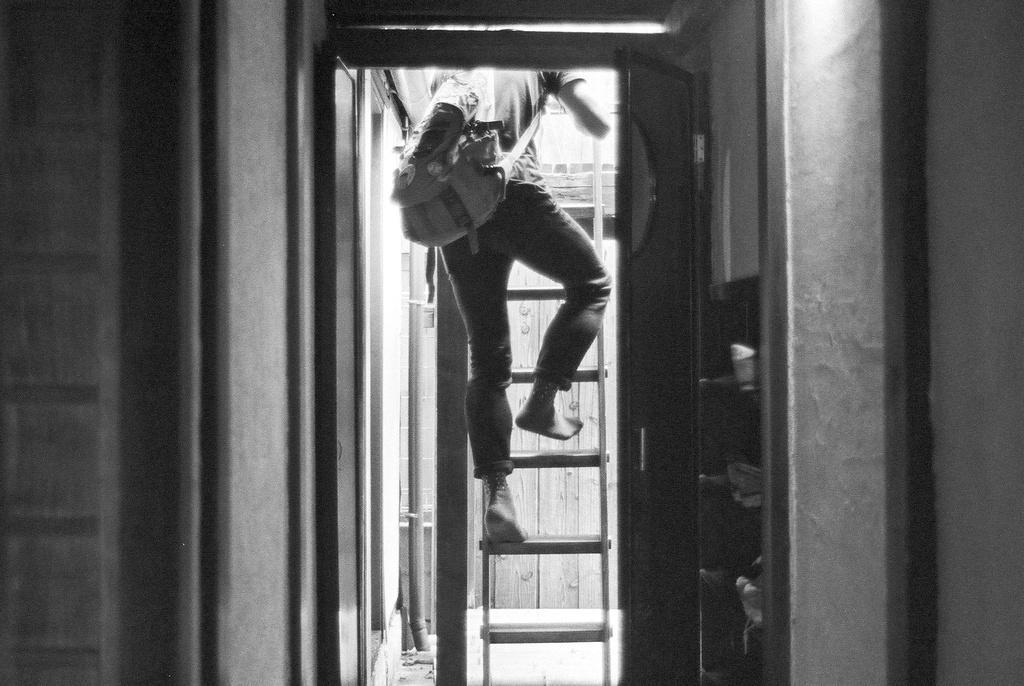Please provide a concise description of this image. In this image I can see a ladder and on it I can see a person. I can see this person is carrying a bag and here on this shelves I can see few things. I can see this image is black and white in colour. 